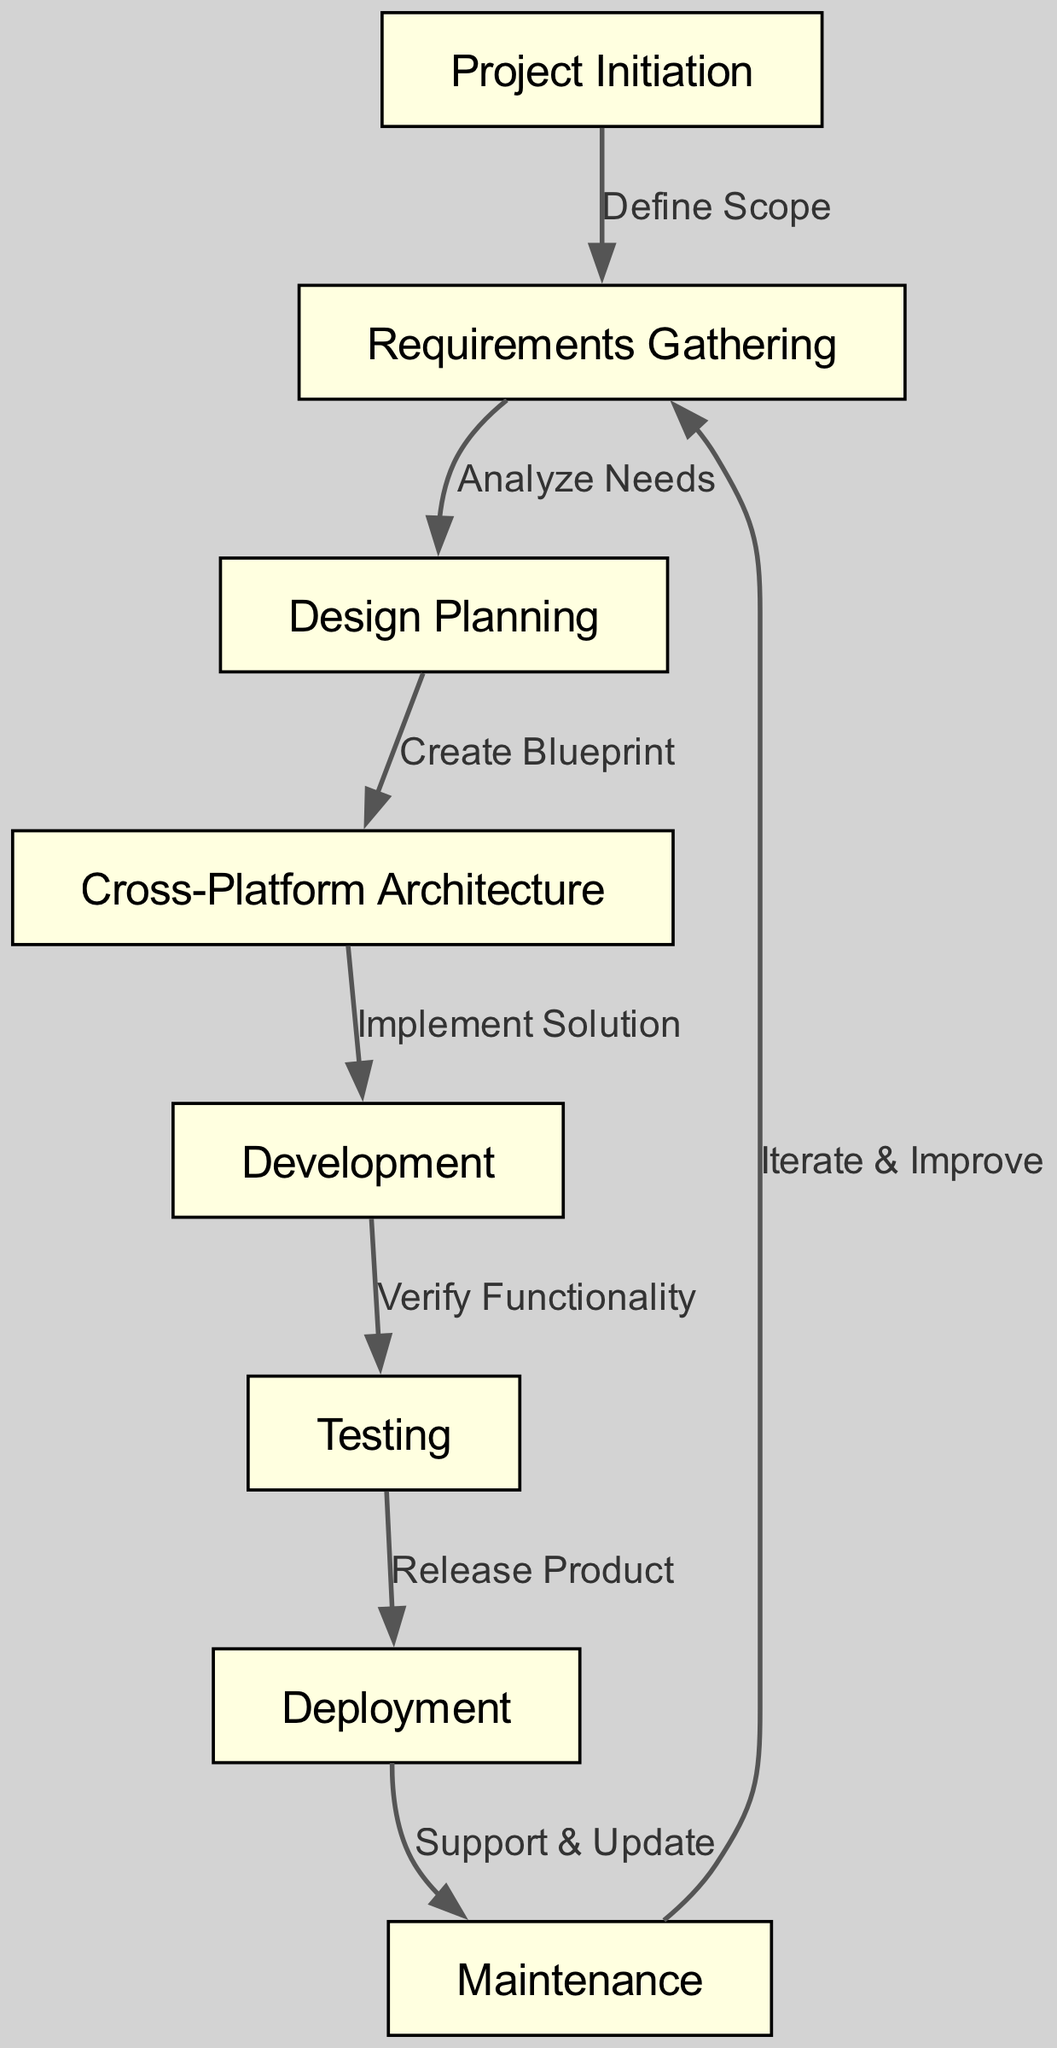What is the first stage in the software development lifecycle? The first stage listed in the diagram is "Project Initiation," which appears at the top of the directed graph.
Answer: Project Initiation How many stages are there in total? By counting the nodes presented in the diagram, there are a total of eight distinct stages outlined.
Answer: Eight What is the relationship labeled between "Development" and "Testing"? The diagram indicates that the edge connecting these two stages is labeled "Verify Functionality," indicating this is the relationship between them.
Answer: Verify Functionality Which stage comes after "Testing"? According to the flow represented in the graph, "Testing" directly leads to the next stage, which is "Deployment."
Answer: Deployment What is the last stage in the lifecycle? The final node in the directed graph is "Maintenance," which is the endpoint of the software development lifecycle illustrated.
Answer: Maintenance Which stage directly leads to "Requirements Gathering" from "Maintenance"? The directed edge labeled "Iterate & Improve" indicates that the stage "Maintenance" leads back to "Requirements Gathering."
Answer: Iterate & Improve What is the overall direction of the flow from "Design Planning"? The flow proceeds from "Design Planning" to "Cross-Platform Architecture," indicating that "Design Planning" feeds into this subsequent stage in the software development lifecycle.
Answer: Cross-Platform Architecture How many edges are there in this directed graph? The diagram includes a total of seven edges, which represent the relationships and flow between the stages indicated.
Answer: Seven What stage is directly connected to "Deployment"? The edge leads from "Deployment" to "Maintenance," showing that "Maintenance" is directly connected to it as a subsequent stage.
Answer: Maintenance 